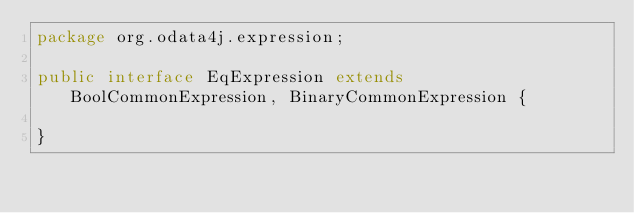<code> <loc_0><loc_0><loc_500><loc_500><_Java_>package org.odata4j.expression;

public interface EqExpression extends BoolCommonExpression, BinaryCommonExpression {

}
</code> 